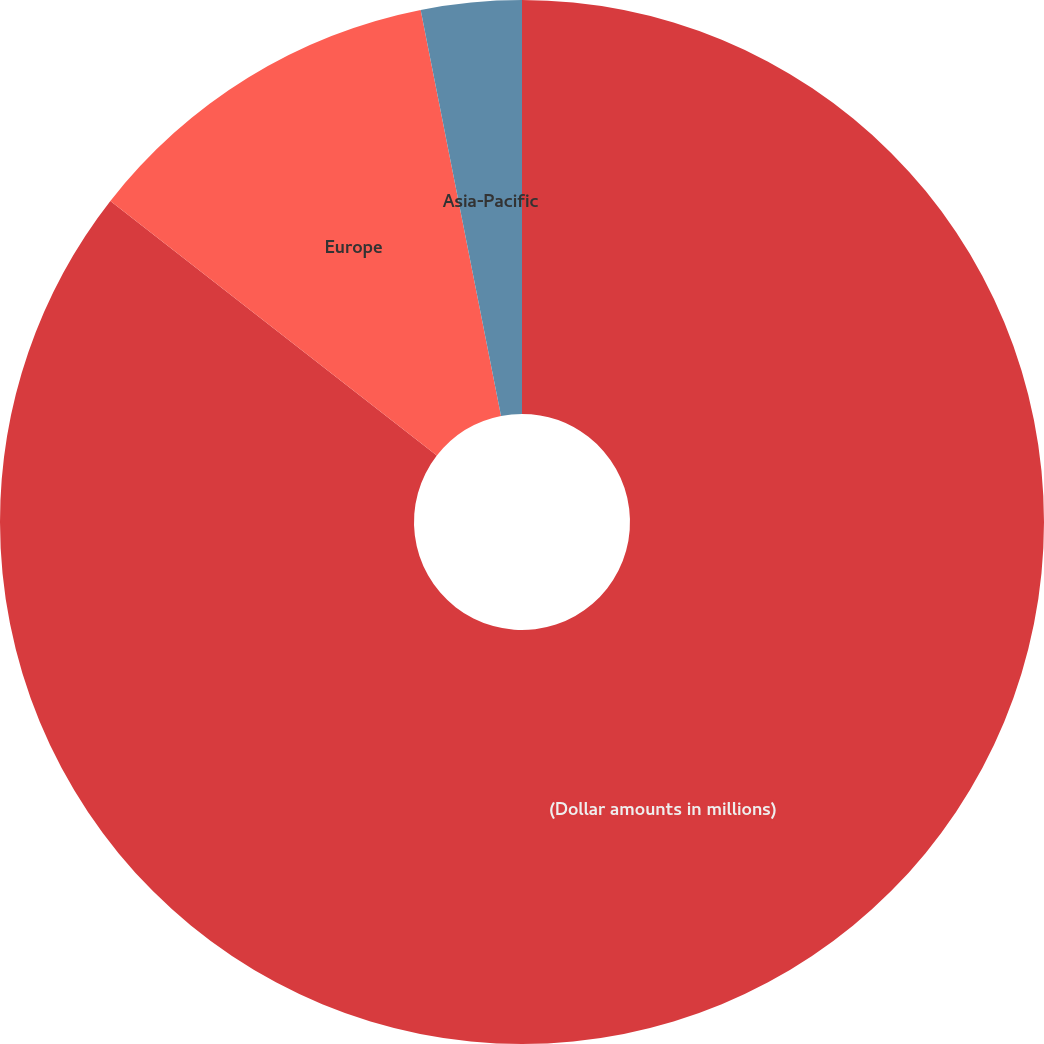<chart> <loc_0><loc_0><loc_500><loc_500><pie_chart><fcel>(Dollar amounts in millions)<fcel>Europe<fcel>Asia-Pacific<nl><fcel>85.55%<fcel>11.35%<fcel>3.11%<nl></chart> 